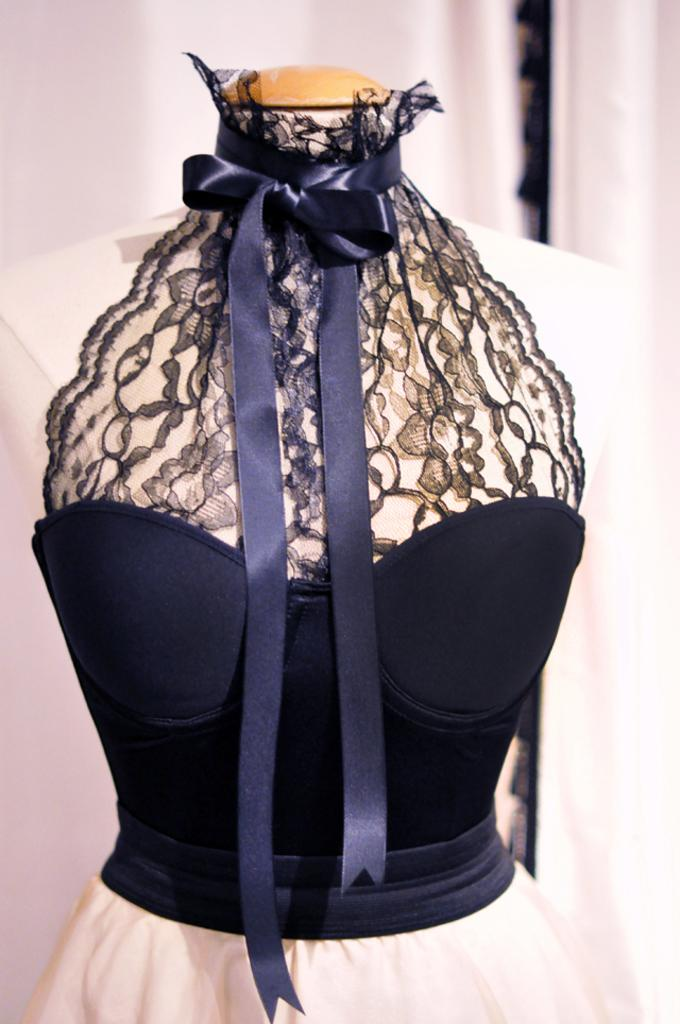What type of clothing is featured in the image? There is a colorful dress in the image. How is the dress being displayed or stored? The dress is attached to a hanger. Where is the bucket located in the image? There is no bucket present in the image. What type of breakfast is being served in the image? There is no breakfast or any food items present in the image. 